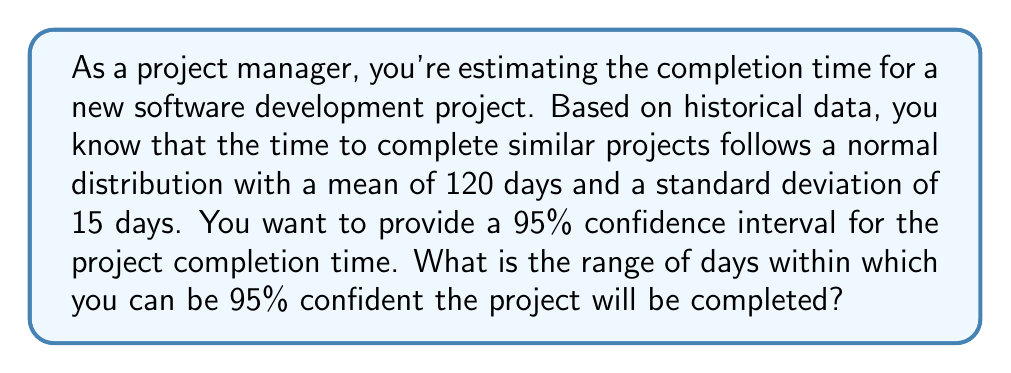Help me with this question. To solve this problem, we'll follow these steps:

1. Identify the given information:
   - Mean (μ) = 120 days
   - Standard deviation (σ) = 15 days
   - Confidence level = 95%

2. Determine the z-score for a 95% confidence interval:
   The z-score for a 95% confidence interval is 1.96 (from the standard normal distribution table).

3. Calculate the margin of error:
   Margin of error = z-score × (σ / √n)
   In this case, n = 1 as we're estimating a single project.
   
   Margin of error = 1.96 × (15 / √1) = 1.96 × 15 = 29.4 days

4. Calculate the confidence interval:
   Lower bound = μ - margin of error
   Upper bound = μ + margin of error

   Lower bound = 120 - 29.4 = 90.6 days
   Upper bound = 120 + 29.4 = 149.4 days

5. Round the results to the nearest whole number of days:
   Lower bound ≈ 91 days
   Upper bound ≈ 149 days

Therefore, we can be 95% confident that the project will be completed between 91 and 149 days.
Answer: 91 to 149 days 